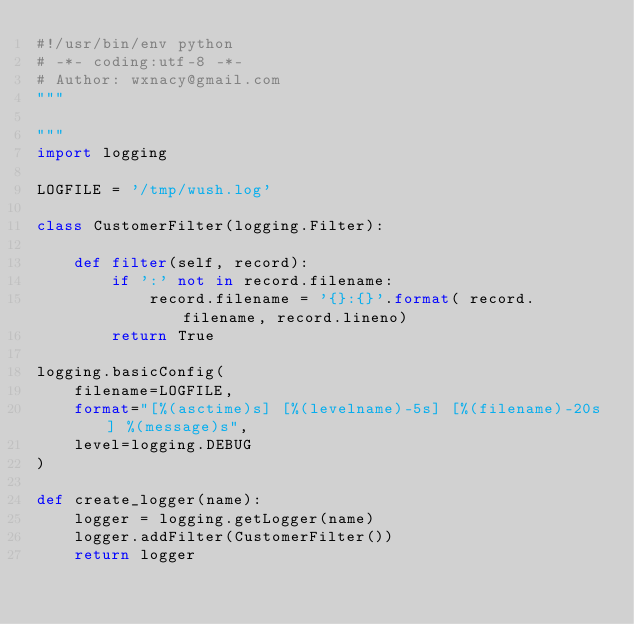<code> <loc_0><loc_0><loc_500><loc_500><_Python_>#!/usr/bin/env python
# -*- coding:utf-8 -*-
# Author: wxnacy@gmail.com
"""

"""
import logging

LOGFILE = '/tmp/wush.log'

class CustomerFilter(logging.Filter):

    def filter(self, record):
        if ':' not in record.filename:
            record.filename = '{}:{}'.format( record.filename, record.lineno)
        return True

logging.basicConfig(
    filename=LOGFILE,
    format="[%(asctime)s] [%(levelname)-5s] [%(filename)-20s] %(message)s",
    level=logging.DEBUG
)

def create_logger(name):
    logger = logging.getLogger(name)
    logger.addFilter(CustomerFilter())
    return logger
</code> 